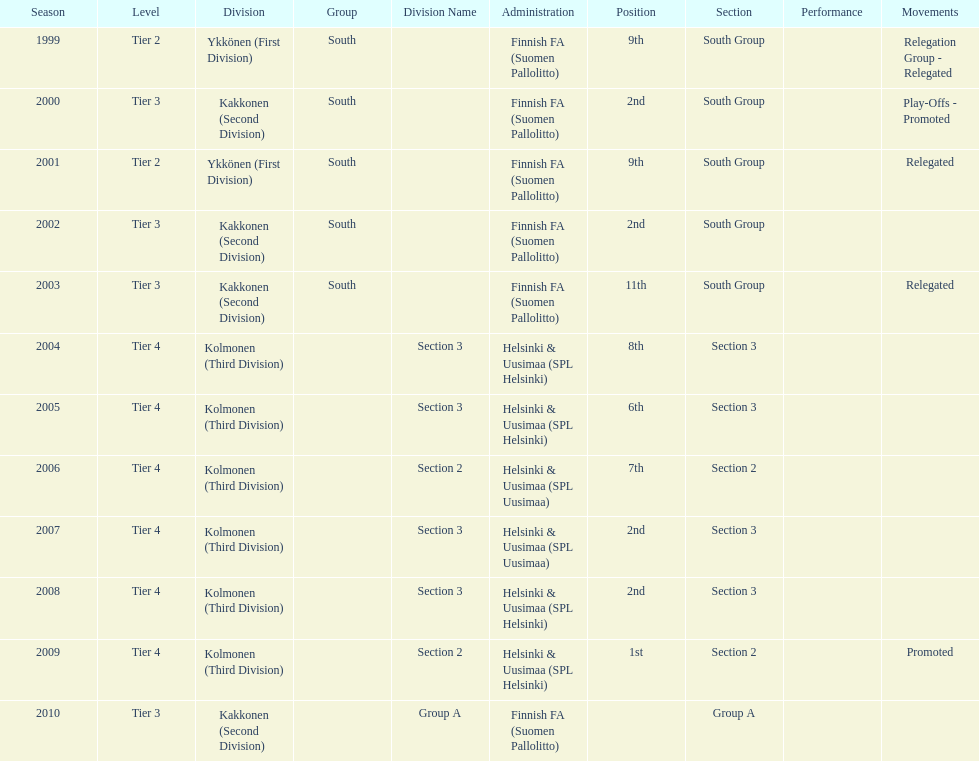What is the first tier listed? Tier 2. 